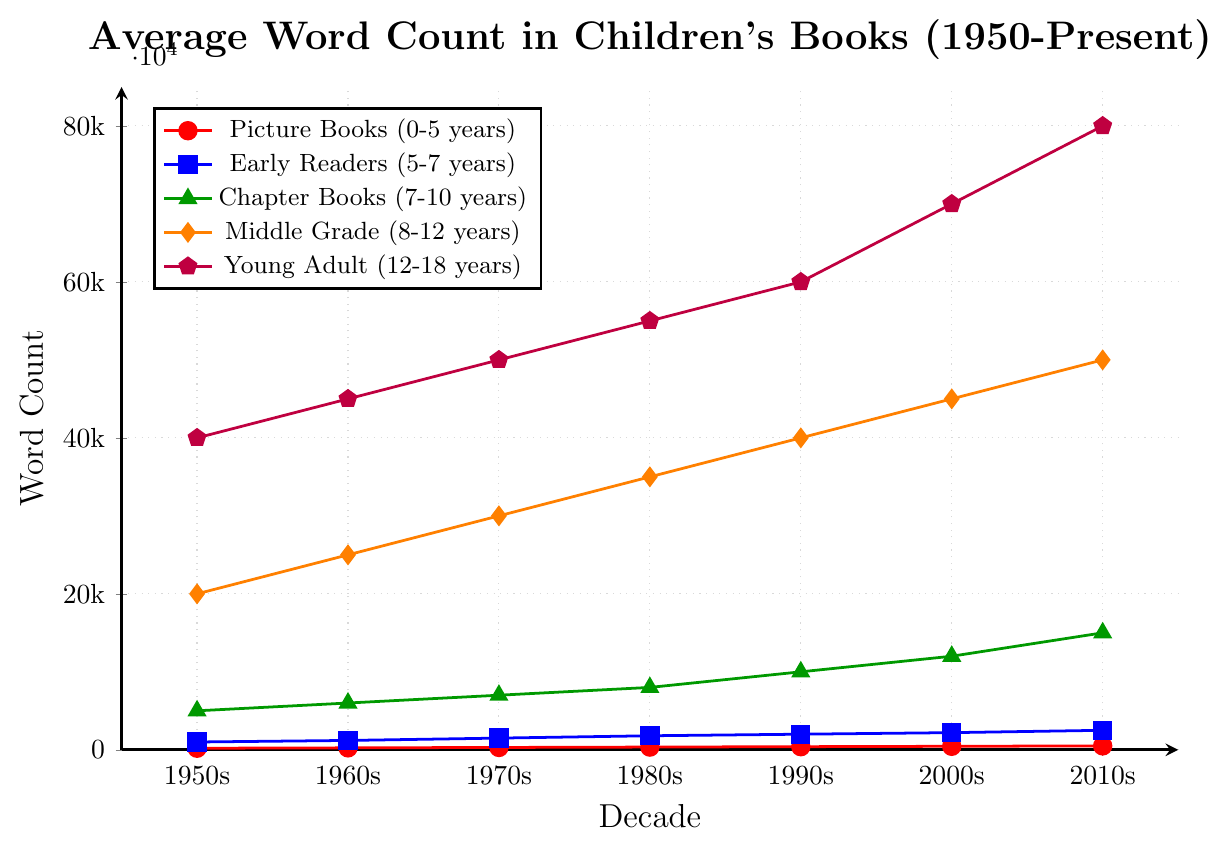What is the general trend in word count for Picture Books from 1950 to the present? The word count for Picture Books generally increases over time. Specifically, it goes from 200 words in the 1950s to 500 words in the 2010s, showing a consistent upward trend across the decades.
Answer: Increasing Which age category has the highest average word count in the 2010s? In the 2010s, the Young Adult (12-18 years) category has the highest average word count at 80,000 words. This is evident from the height of the purple line with pentagon marks, which is the tallest in the chart for that decade.
Answer: Young Adult What is the difference in word count between Middle Grade and Chapter Books in the 1990s? Middle Grade has about 40,000 words and Chapter Books have about 10,000 words in the 1990s. The difference in word count is 40,000 - 10,000 = 30,000.
Answer: 30,000 Which age group saw the most significant increase in word count from the 1950s to the 2010s? Young Adult books saw the most significant increase, going from 40,000 words in the 1950s to 80,000 words in the 2010s, which is an increase of 40,000 words. This can be seen by the significant growth in the purple line with pentagon marks.
Answer: Young Adult How does the word count in Early Readers in the 1970s compare with the word count in Chapter Books in the same decade? In the 1970s, Early Readers have an average word count of 1500, while Chapter Books have a word count of 7000. Chapter Books have a significantly higher word count by 7000 - 1500 = 5500 words.
Answer: Chapter Books are higher by 5500 words What is the average word count for Chapter Books over all the decades provided? To find the average, add the word counts for each decade and then divide by the number of decades: (5000 + 6000 + 7000 + 8000 + 10000 + 12000 + 15000) / 7 = 8,857 words.
Answer: 8,857 words Does any age group show a decline in word count from any decade to the next? No, all age groups show an increasing trend in word count from one decade to the next. Evidence can be seen with each line going progressively upwards for all categories across the provided decades.
Answer: No Which line/age group is represented in green with triangle markers, and what does it signify? The green line with triangle markers represents Chapter Books (7-10 years). It signifies the average word count for this age category over the decades.
Answer: Chapter Books (7-10 years) What is the percentage increase in word count for Picture Books from the 1950s to the 2010s? To find the percentage increase: New Value = 500, Original Value = 200. Increase = 500 - 200 = 300. Percentage Increase = (300 / 200) * 100 = 150%.
Answer: 150% In which decade did the Middle Grade category see the largest increase in word count compared to the previous decade? The largest increase for Middle Grade books occurred between the 1990s and the 2000s, where it increased from 40,000 words to 45,000 words, showing a growth of 5,000 words.
Answer: 1990s to 2000s 